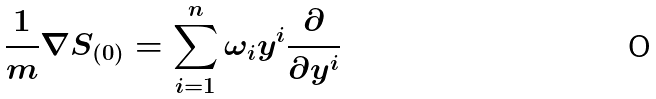<formula> <loc_0><loc_0><loc_500><loc_500>\frac { 1 } { m } \nabla S _ { ( 0 ) } = \sum _ { i = 1 } ^ { n } \omega _ { i } y ^ { i } \frac { \partial } { \partial y ^ { i } }</formula> 